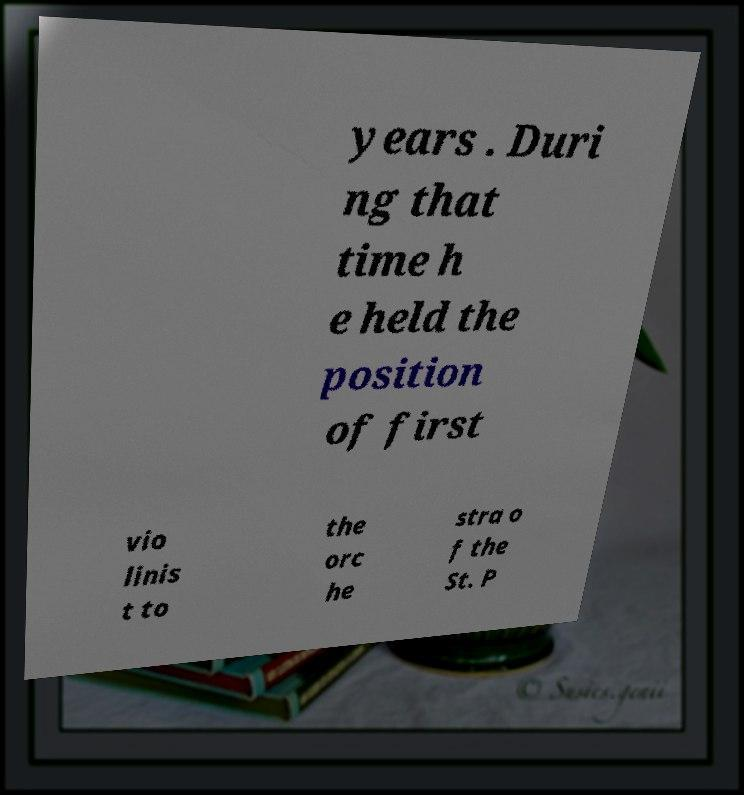Could you extract and type out the text from this image? years . Duri ng that time h e held the position of first vio linis t to the orc he stra o f the St. P 